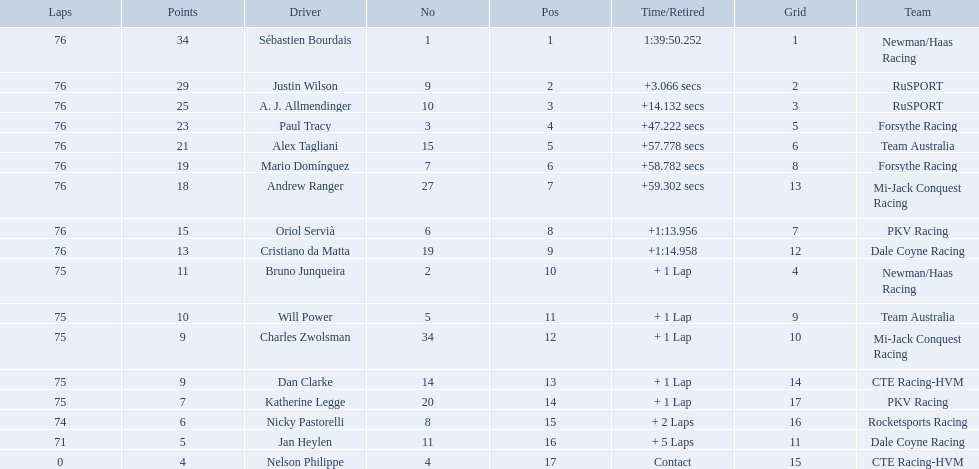What was alex taglini's final score in the tecate grand prix? 21. What was paul tracy's final score in the tecate grand prix? 23. Which driver finished first? Paul Tracy. 